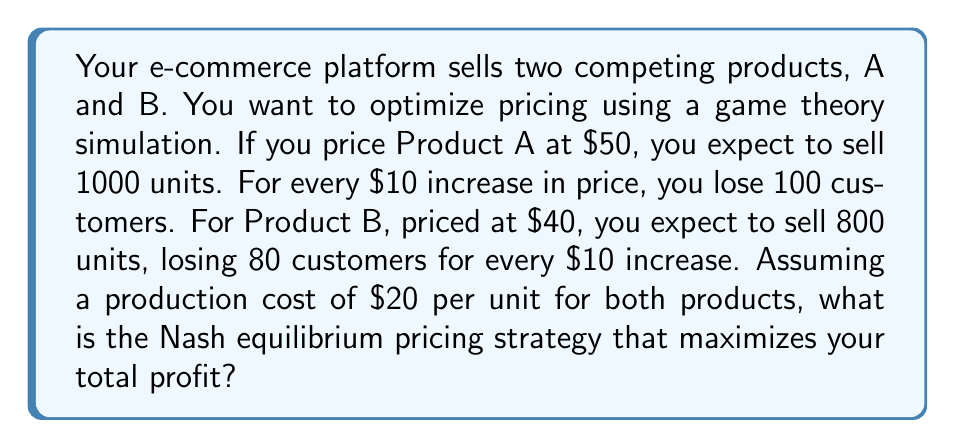Teach me how to tackle this problem. Let's approach this step-by-step:

1) First, let's define our profit functions for each product:

   For Product A: $\pi_A(p_A) = (p_A - 20)(1000 - 10(p_A - 50))$
   For Product B: $\pi_B(p_B) = (p_B - 20)(800 - 8(p_B - 40))$

2) To find the Nash equilibrium, we need to find the best response functions for each product:

3) For Product A:
   $$\frac{d\pi_A}{dp_A} = 1000 - 10(p_A - 50) - 10(p_A - 20) = 0$$
   $$1500 - 20p_A = 0$$
   $$p_A = 75$$

4) For Product B:
   $$\frac{d\pi_B}{dp_B} = 800 - 8(p_B - 40) - 8(p_B - 20) = 0$$
   $$1120 - 16p_B = 0$$
   $$p_B = 70$$

5) The Nash equilibrium is the point where both best response functions intersect, which is $(75, 70)$.

6) Let's verify the profits at this point:

   For A: $\pi_A(75) = (75 - 20)(1000 - 10(75 - 50)) = 55 * 750 = 41,250$
   For B: $\pi_B(70) = (70 - 20)(800 - 8(70 - 40)) = 50 * 560 = 28,000$

   Total profit: $41,250 + 28,000 = 69,250$

Therefore, the Nash equilibrium pricing strategy that maximizes total profit is to price Product A at $75 and Product B at $70.
Answer: Product A: $75, Product B: $70 